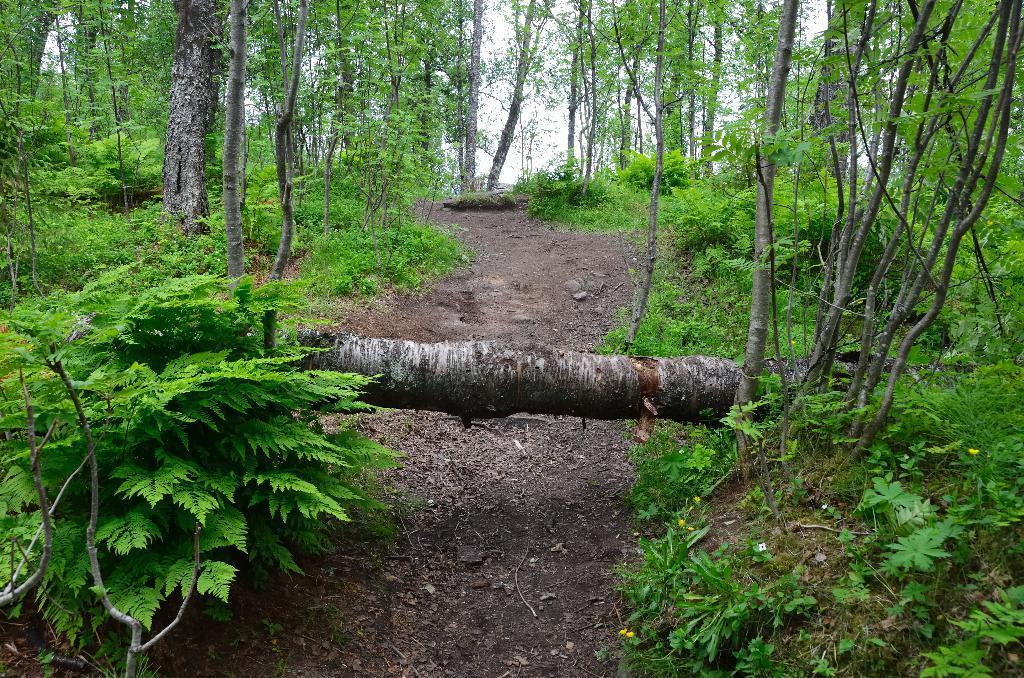What type of environment is depicted in the image? The image appears to be taken in a forest. What can be seen at the bottom of the image? There is a path at the bottom of the image. What is present on both the left and right sides of the image? Trees are present on both the left and right sides of the image. What color are the plants visible in the image? Green-colored plants are visible in the image. Can you hear the sound of a drum in the image? There is no sound present in the image, so it is not possible to hear a drum. Is there a tub visible in the image? There is no tub present in the image. 